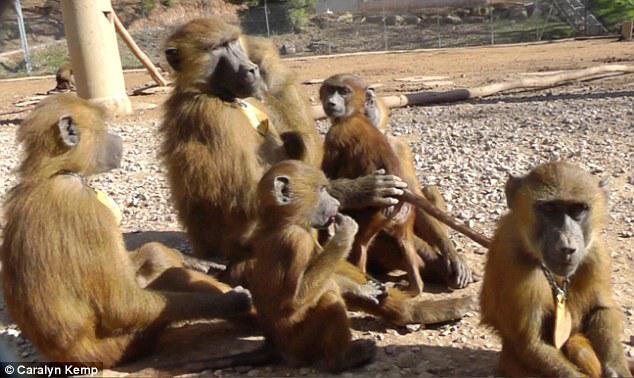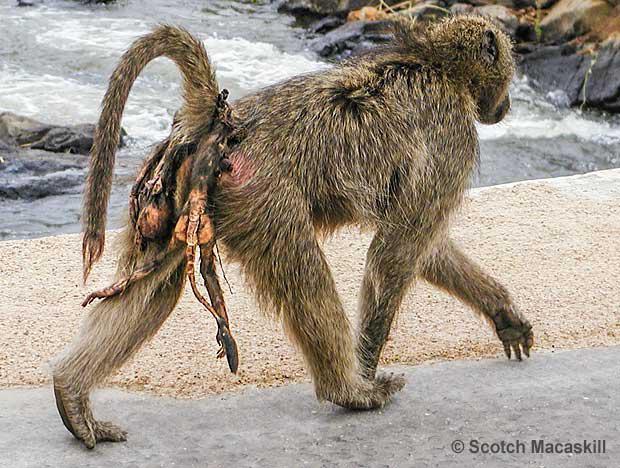The first image is the image on the left, the second image is the image on the right. For the images shown, is this caption "There are at most 4 monkeys in total" true? Answer yes or no. No. 